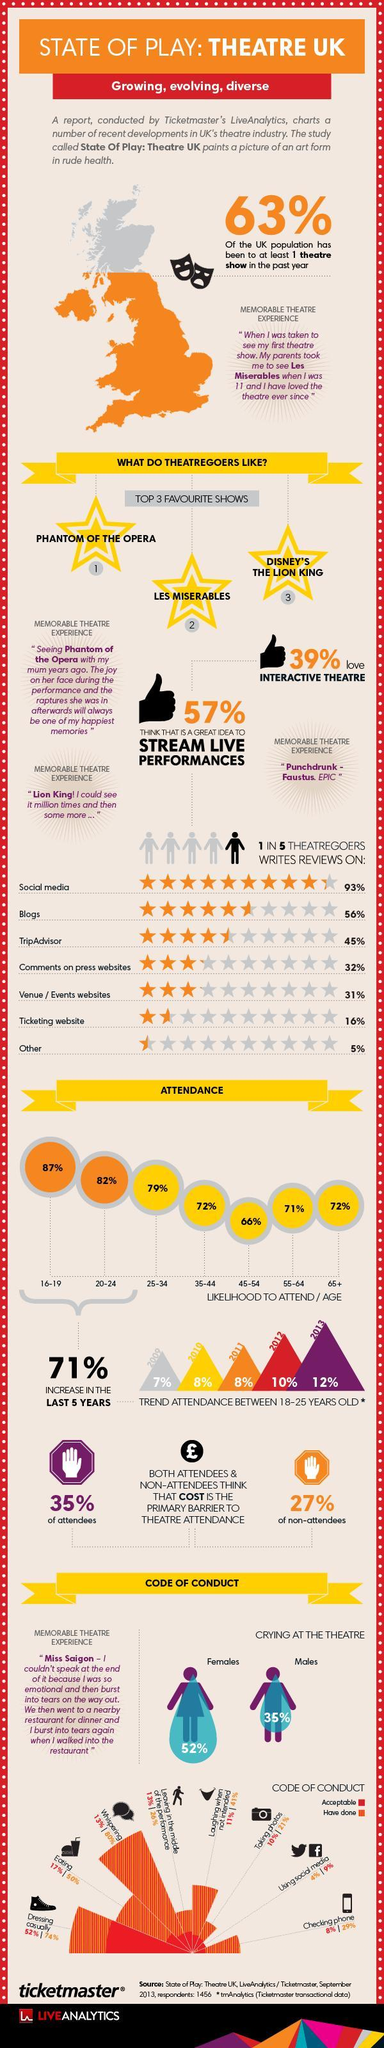Which age group is less likely to attend ?
Answer the question with a short phrase. 45-54 What is written just below the heading? growing, evolving, diverse What is the percentage increase of 16-24 age group attendance in the last five years? 71% Which platform is mostly user to write reviews after social media? blogs People of which age group has attended the show more - 45-54 or 55-64? 55-64 What percentage of theatregoers write reviews? 20 What percentage of the UK population did not attend any theater show last year? 37% Which is the third most favorite show? Disney's the lion king What are the three most favorite shows? phantom of the opera, les miserables, Disney's the lion king Who is more likely to cry at the theater? females What is the trend in attendance of 18-25 old from 2009 to 2013 - increasing or decreasing? increasing What is the second most favorite show? les miserables, 